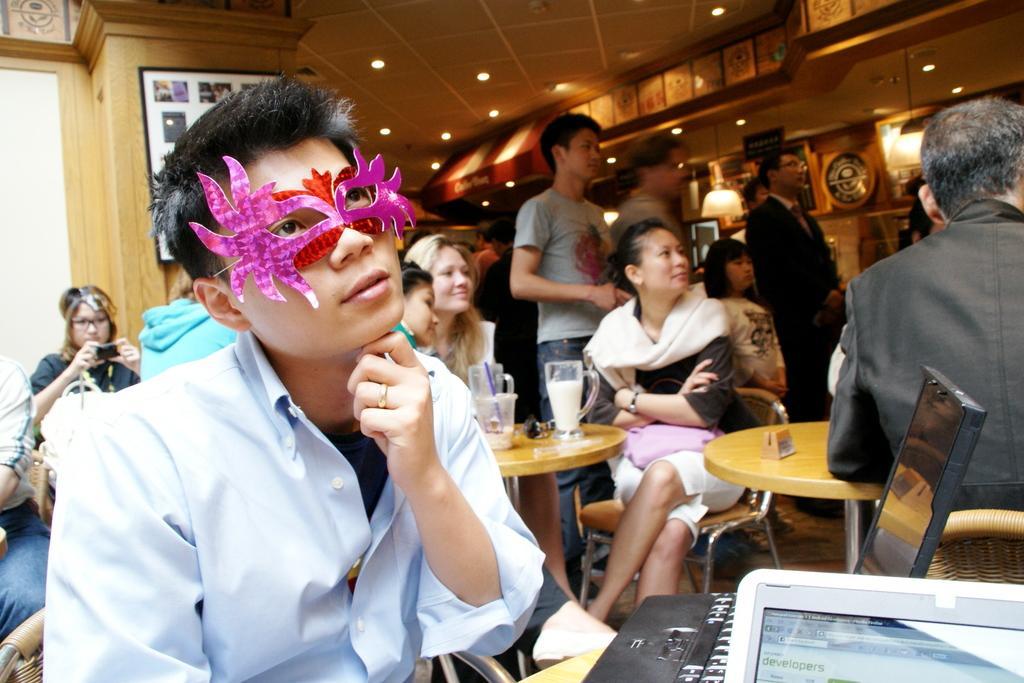How would you summarize this image in a sentence or two? In this image I can see number of people were few of them are standing and rest all are standing. Here I can see a man wearing a face mask. In the background I can see a frame on this wall. 